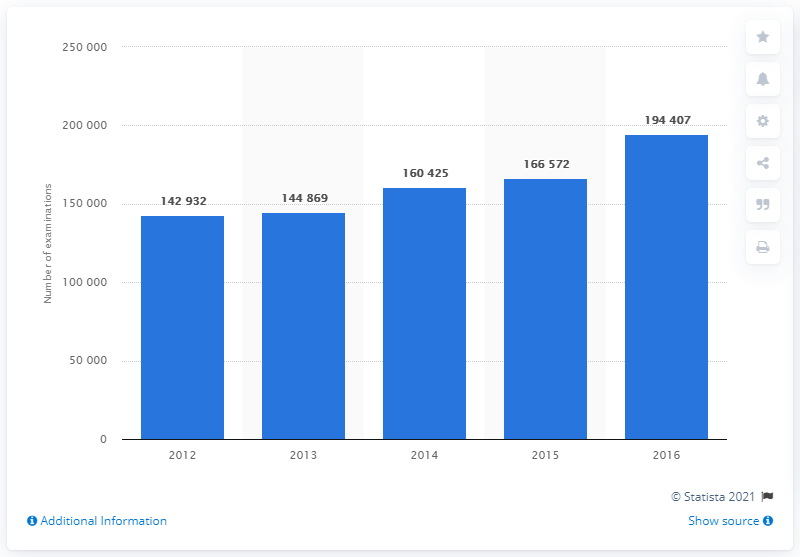Highlight a few significant elements in this photo. In 2016, a total of 194,407 MRI scan examinations were conducted in Croatia. 